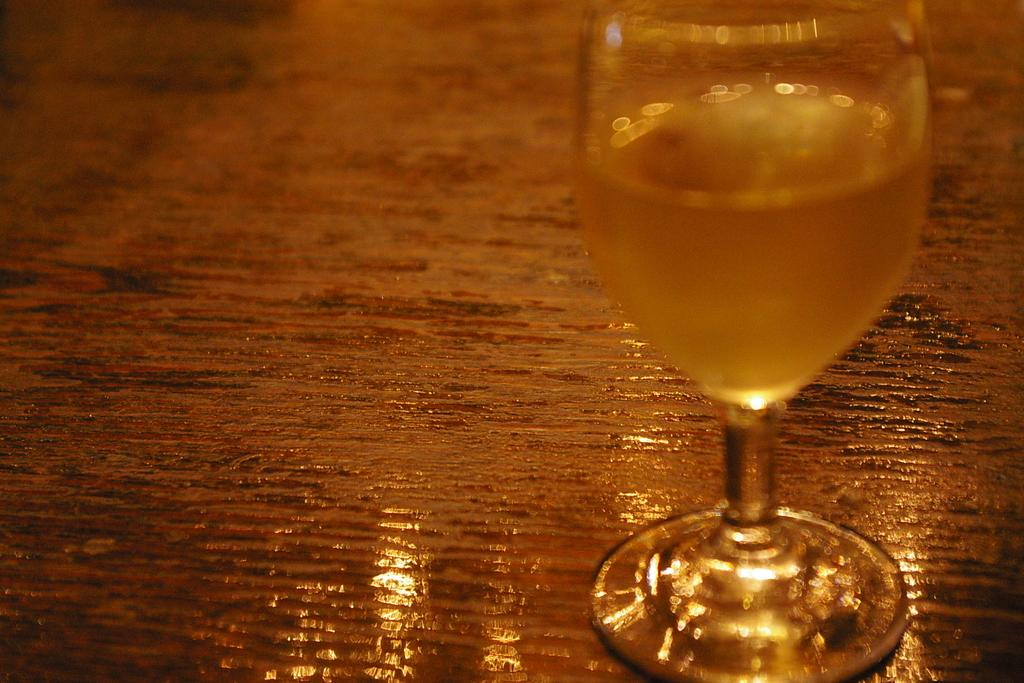What object in the image is used for holding liquids? There is a glass in the image that is used for holding liquids. What is inside the glass in the image? The glass contains a drink. How far can the memory of the drink be traced back in the image? There is no mention of memory in the image, as it only shows a glass containing a drink. 